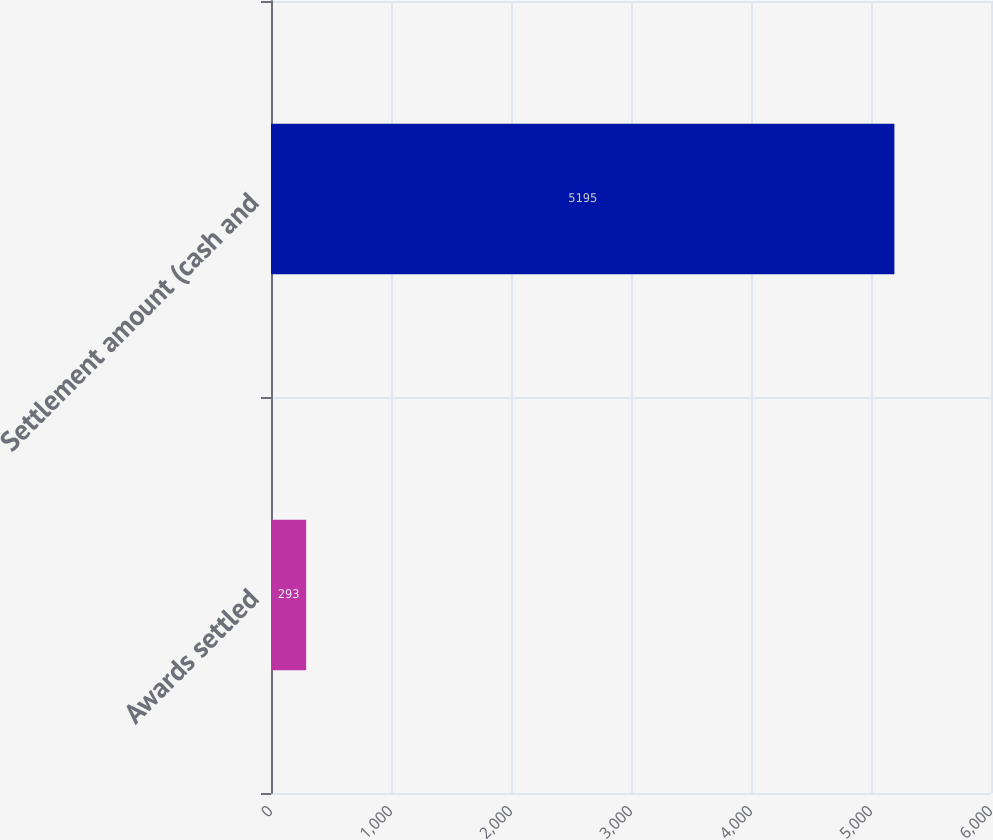Convert chart to OTSL. <chart><loc_0><loc_0><loc_500><loc_500><bar_chart><fcel>Awards settled<fcel>Settlement amount (cash and<nl><fcel>293<fcel>5195<nl></chart> 